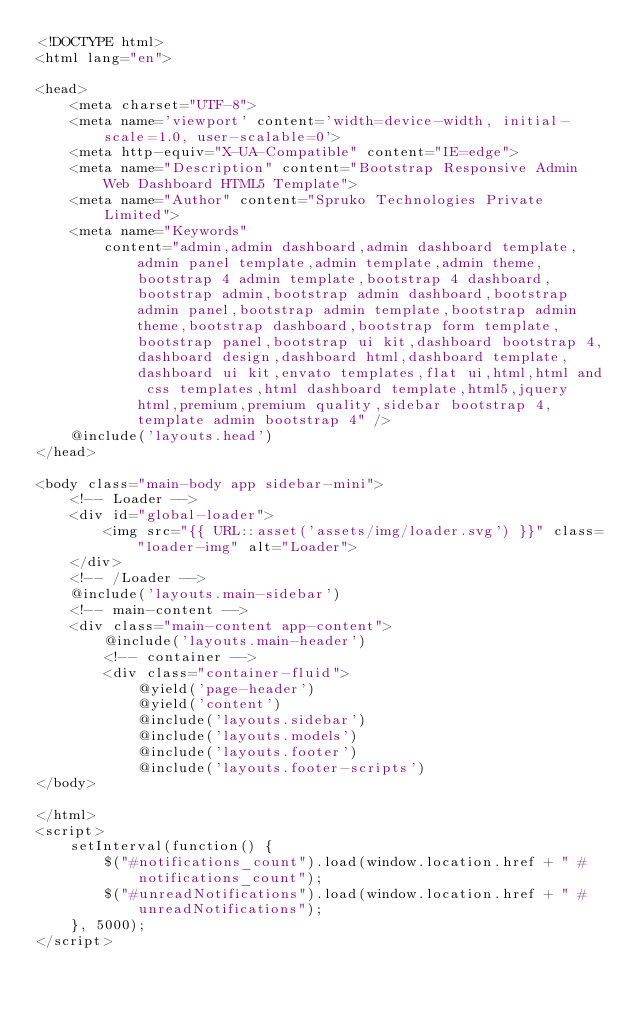<code> <loc_0><loc_0><loc_500><loc_500><_PHP_><!DOCTYPE html>
<html lang="en">

<head>
    <meta charset="UTF-8">
    <meta name='viewport' content='width=device-width, initial-scale=1.0, user-scalable=0'>
    <meta http-equiv="X-UA-Compatible" content="IE=edge">
    <meta name="Description" content="Bootstrap Responsive Admin Web Dashboard HTML5 Template">
    <meta name="Author" content="Spruko Technologies Private Limited">
    <meta name="Keywords"
        content="admin,admin dashboard,admin dashboard template,admin panel template,admin template,admin theme,bootstrap 4 admin template,bootstrap 4 dashboard,bootstrap admin,bootstrap admin dashboard,bootstrap admin panel,bootstrap admin template,bootstrap admin theme,bootstrap dashboard,bootstrap form template,bootstrap panel,bootstrap ui kit,dashboard bootstrap 4,dashboard design,dashboard html,dashboard template,dashboard ui kit,envato templates,flat ui,html,html and css templates,html dashboard template,html5,jquery html,premium,premium quality,sidebar bootstrap 4,template admin bootstrap 4" />
    @include('layouts.head')
</head>

<body class="main-body app sidebar-mini">
    <!-- Loader -->
    <div id="global-loader">
        <img src="{{ URL::asset('assets/img/loader.svg') }}" class="loader-img" alt="Loader">
    </div>
    <!-- /Loader -->
    @include('layouts.main-sidebar')
    <!-- main-content -->
    <div class="main-content app-content">
        @include('layouts.main-header')
        <!-- container -->
        <div class="container-fluid">
            @yield('page-header')
            @yield('content')
            @include('layouts.sidebar')
            @include('layouts.models')
            @include('layouts.footer')
            @include('layouts.footer-scripts')
</body>

</html>
<script>
    setInterval(function() {
        $("#notifications_count").load(window.location.href + " #notifications_count");
        $("#unreadNotifications").load(window.location.href + " #unreadNotifications");
    }, 5000);
</script>
</code> 